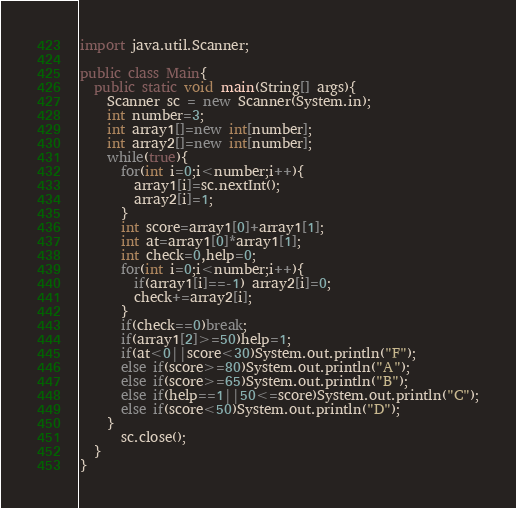Convert code to text. <code><loc_0><loc_0><loc_500><loc_500><_Java_>import java.util.Scanner;

public class Main{
  public static void main(String[] args){
    Scanner sc = new Scanner(System.in);
    int number=3;
    int array1[]=new int[number];
    int array2[]=new int[number];
    while(true){
      for(int i=0;i<number;i++){
        array1[i]=sc.nextInt();
        array2[i]=1;
      }
      int score=array1[0]+array1[1];
      int at=array1[0]*array1[1];
      int check=0,help=0;
      for(int i=0;i<number;i++){
        if(array1[i]==-1) array2[i]=0;
        check+=array2[i];
      }
      if(check==0)break;
      if(array1[2]>=50)help=1;
      if(at<0||score<30)System.out.println("F");
      else if(score>=80)System.out.println("A");
      else if(score>=65)System.out.println("B");
      else if(help==1||50<=score)System.out.println("C");
      else if(score<50)System.out.println("D");
    }
      sc.close();
  }
}
</code> 